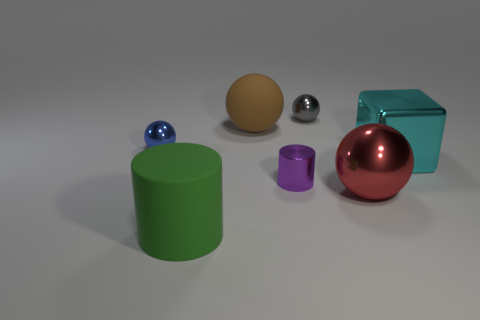Are there fewer purple metallic cylinders than green matte spheres?
Provide a succinct answer. No. There is a blue shiny sphere that is behind the green rubber object left of the cyan metal thing; how many rubber objects are behind it?
Ensure brevity in your answer.  1. There is a big brown matte thing; how many balls are behind it?
Provide a succinct answer. 1. The other tiny shiny object that is the same shape as the blue metallic thing is what color?
Ensure brevity in your answer.  Gray. There is a thing that is behind the tiny blue metal object and in front of the gray metal thing; what is it made of?
Give a very brief answer. Rubber. Does the sphere that is on the right side of the gray object have the same size as the tiny gray thing?
Provide a succinct answer. No. What material is the brown sphere?
Your answer should be very brief. Rubber. The cylinder right of the green cylinder is what color?
Provide a succinct answer. Purple. How many tiny things are brown things or green things?
Ensure brevity in your answer.  0. How many brown things are cubes or big spheres?
Offer a very short reply. 1. 